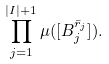Convert formula to latex. <formula><loc_0><loc_0><loc_500><loc_500>\prod _ { j = 1 } ^ { | I | + 1 } \mu ( [ B _ { j } ^ { \bar { r } _ { j } } ] ) .</formula> 